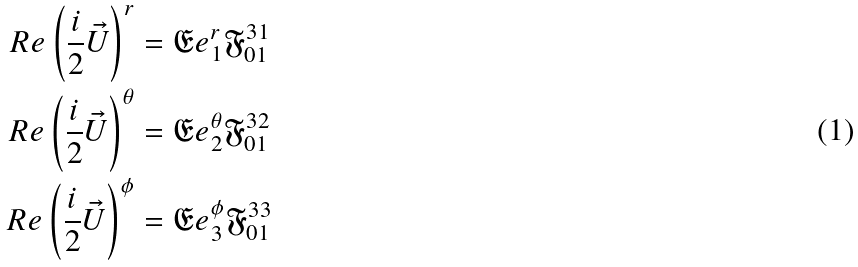Convert formula to latex. <formula><loc_0><loc_0><loc_500><loc_500>R e \left ( \frac { i } { 2 } \vec { U } \right ) ^ { r } & = \mathfrak { E } e ^ { r } _ { 1 } \mathfrak { F } ^ { 3 1 } _ { 0 1 } \\ R e \left ( \frac { i } { 2 } \vec { U } \right ) ^ { \theta } & = \mathfrak { E } e ^ { \theta } _ { 2 } \mathfrak { F } ^ { 3 2 } _ { 0 1 } \\ R e \left ( \frac { i } { 2 } \vec { U } \right ) ^ { \phi } & = \mathfrak { E } e ^ { \phi } _ { 3 } \mathfrak { F } ^ { 3 3 } _ { 0 1 }</formula> 